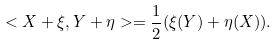Convert formula to latex. <formula><loc_0><loc_0><loc_500><loc_500>< X + \xi , Y + \eta > = \frac { 1 } { 2 } ( \xi ( Y ) + \eta ( X ) ) .</formula> 